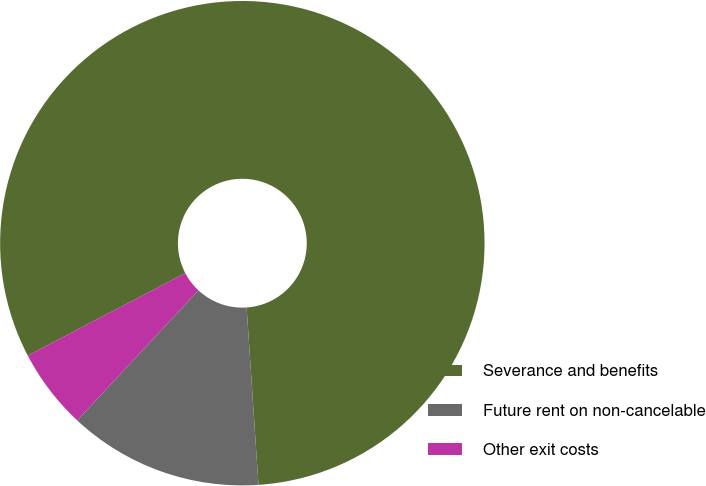Convert chart. <chart><loc_0><loc_0><loc_500><loc_500><pie_chart><fcel>Severance and benefits<fcel>Future rent on non-cancelable<fcel>Other exit costs<nl><fcel>81.61%<fcel>13.0%<fcel>5.38%<nl></chart> 